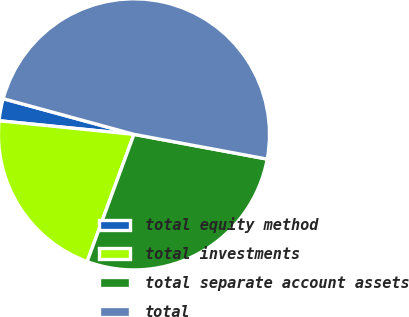Convert chart to OTSL. <chart><loc_0><loc_0><loc_500><loc_500><pie_chart><fcel>total equity method<fcel>total investments<fcel>total separate account assets<fcel>total<nl><fcel>2.64%<fcel>20.99%<fcel>27.69%<fcel>48.68%<nl></chart> 